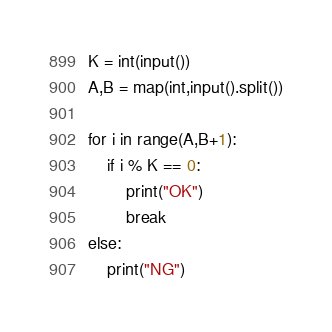Convert code to text. <code><loc_0><loc_0><loc_500><loc_500><_Python_>K = int(input())
A,B = map(int,input().split())

for i in range(A,B+1):
    if i % K == 0:
        print("OK")
        break
else:
    print("NG")</code> 